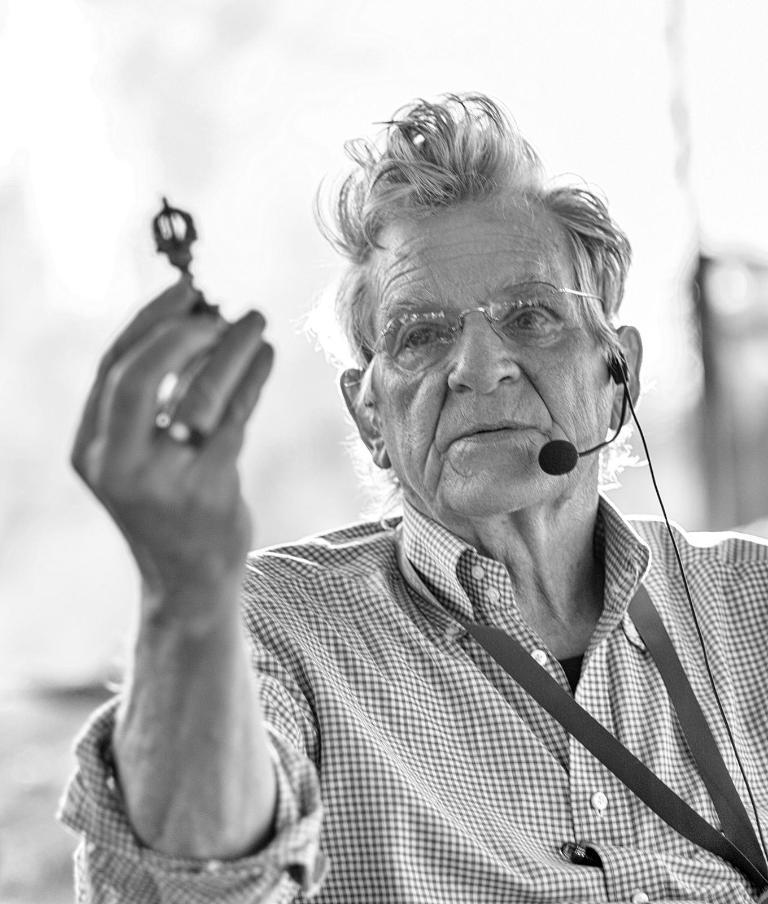Describe this image in one or two sentences. This is a black and white image of an old man in checkered shirt and mic holding a key. 